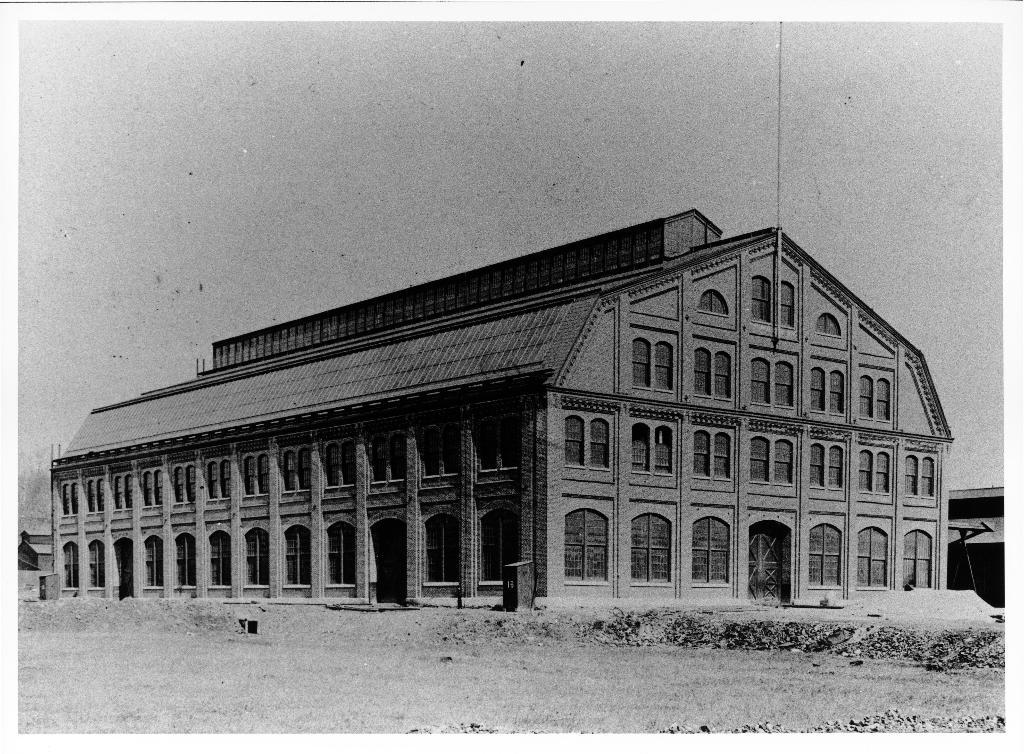What is the color scheme of the image? The image is black and white. What structure is present in the image? There is a building in the image. What features can be observed on the building? The building has a roof, doors, and windows. What is visible in the background of the image? The sky is visible in the image. How many pins are attached to the ball in the image? There is no ball or pins present in the image. 